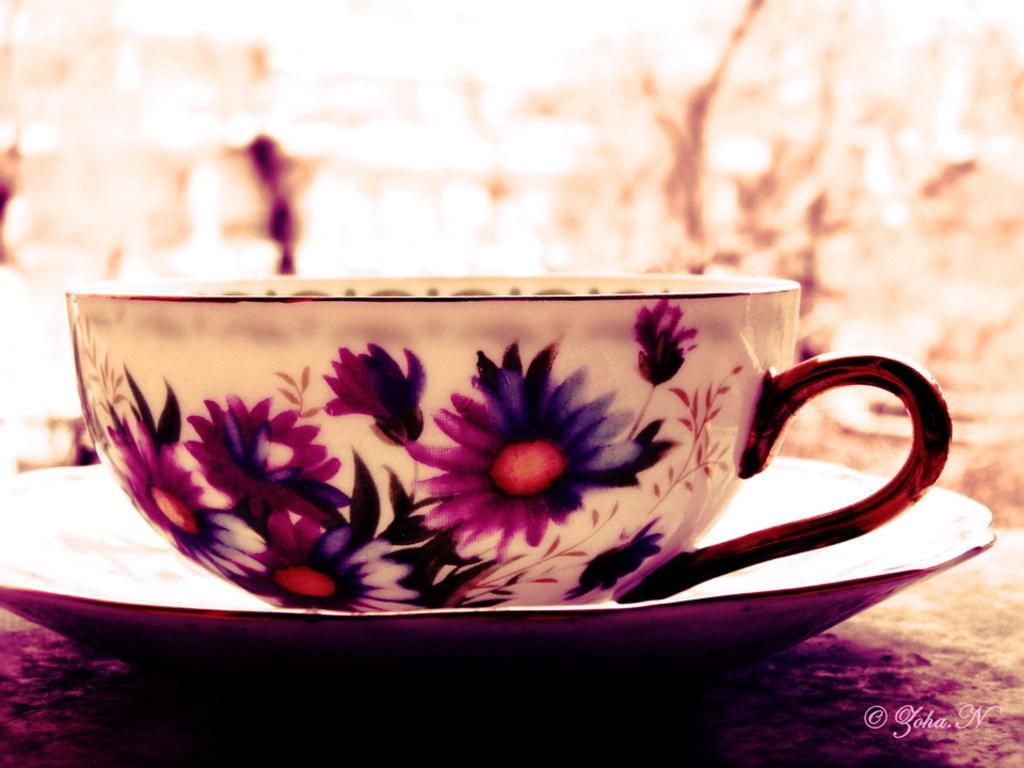In one or two sentences, can you explain what this image depicts? In the picture we can see cup and saucer on the cup we can see some flower paintings. 